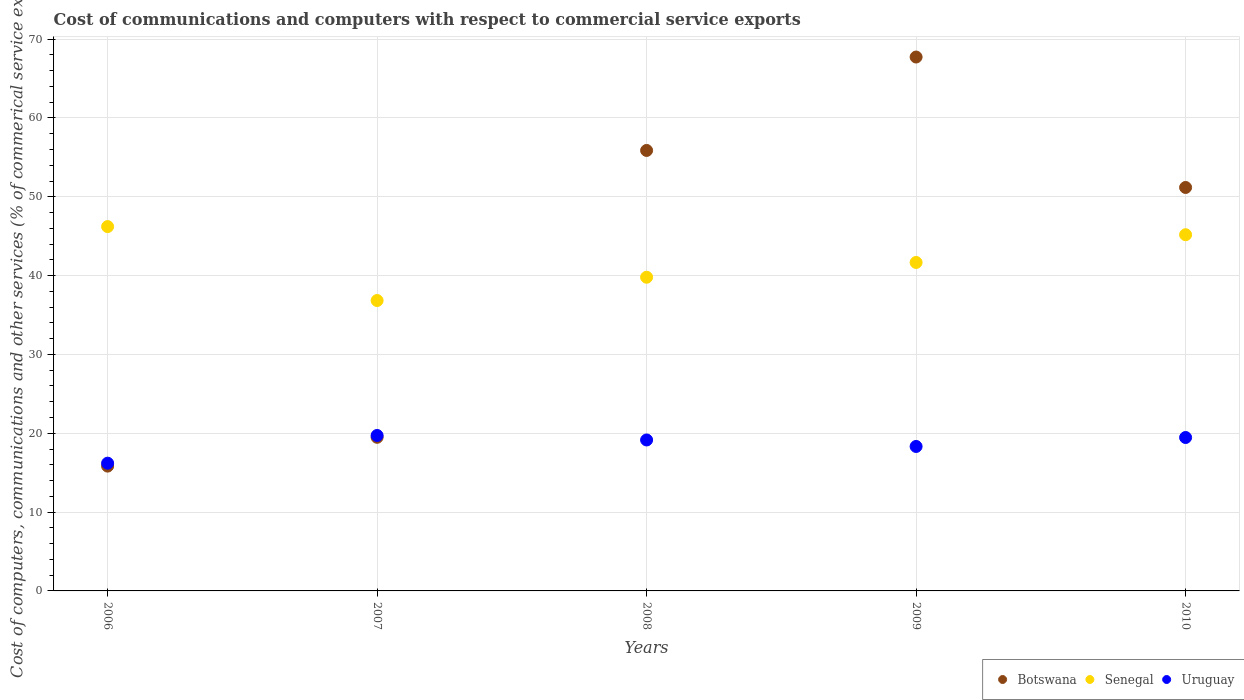What is the cost of communications and computers in Botswana in 2010?
Give a very brief answer. 51.18. Across all years, what is the maximum cost of communications and computers in Uruguay?
Keep it short and to the point. 19.72. Across all years, what is the minimum cost of communications and computers in Botswana?
Your answer should be very brief. 15.83. In which year was the cost of communications and computers in Senegal maximum?
Your response must be concise. 2006. In which year was the cost of communications and computers in Senegal minimum?
Your answer should be very brief. 2007. What is the total cost of communications and computers in Botswana in the graph?
Your answer should be compact. 210.1. What is the difference between the cost of communications and computers in Uruguay in 2006 and that in 2009?
Your answer should be very brief. -2.12. What is the difference between the cost of communications and computers in Senegal in 2010 and the cost of communications and computers in Botswana in 2008?
Your answer should be very brief. -10.69. What is the average cost of communications and computers in Senegal per year?
Your answer should be compact. 41.94. In the year 2008, what is the difference between the cost of communications and computers in Botswana and cost of communications and computers in Uruguay?
Keep it short and to the point. 36.73. In how many years, is the cost of communications and computers in Botswana greater than 58 %?
Offer a very short reply. 1. What is the ratio of the cost of communications and computers in Senegal in 2007 to that in 2010?
Your answer should be very brief. 0.82. Is the difference between the cost of communications and computers in Botswana in 2007 and 2009 greater than the difference between the cost of communications and computers in Uruguay in 2007 and 2009?
Ensure brevity in your answer.  No. What is the difference between the highest and the second highest cost of communications and computers in Senegal?
Give a very brief answer. 1.03. What is the difference between the highest and the lowest cost of communications and computers in Uruguay?
Give a very brief answer. 3.52. In how many years, is the cost of communications and computers in Uruguay greater than the average cost of communications and computers in Uruguay taken over all years?
Offer a very short reply. 3. Is the cost of communications and computers in Senegal strictly greater than the cost of communications and computers in Botswana over the years?
Your answer should be very brief. No. Is the cost of communications and computers in Botswana strictly less than the cost of communications and computers in Uruguay over the years?
Offer a terse response. No. How many years are there in the graph?
Keep it short and to the point. 5. Does the graph contain any zero values?
Your answer should be compact. No. Does the graph contain grids?
Offer a very short reply. Yes. How are the legend labels stacked?
Ensure brevity in your answer.  Horizontal. What is the title of the graph?
Your answer should be very brief. Cost of communications and computers with respect to commercial service exports. What is the label or title of the Y-axis?
Give a very brief answer. Cost of computers, communications and other services (% of commerical service exports). What is the Cost of computers, communications and other services (% of commerical service exports) in Botswana in 2006?
Your answer should be compact. 15.83. What is the Cost of computers, communications and other services (% of commerical service exports) in Senegal in 2006?
Provide a short and direct response. 46.22. What is the Cost of computers, communications and other services (% of commerical service exports) in Uruguay in 2006?
Offer a terse response. 16.2. What is the Cost of computers, communications and other services (% of commerical service exports) in Botswana in 2007?
Make the answer very short. 19.49. What is the Cost of computers, communications and other services (% of commerical service exports) in Senegal in 2007?
Your answer should be very brief. 36.84. What is the Cost of computers, communications and other services (% of commerical service exports) in Uruguay in 2007?
Your response must be concise. 19.72. What is the Cost of computers, communications and other services (% of commerical service exports) of Botswana in 2008?
Provide a succinct answer. 55.88. What is the Cost of computers, communications and other services (% of commerical service exports) in Senegal in 2008?
Offer a terse response. 39.79. What is the Cost of computers, communications and other services (% of commerical service exports) of Uruguay in 2008?
Make the answer very short. 19.15. What is the Cost of computers, communications and other services (% of commerical service exports) in Botswana in 2009?
Provide a succinct answer. 67.73. What is the Cost of computers, communications and other services (% of commerical service exports) of Senegal in 2009?
Provide a short and direct response. 41.67. What is the Cost of computers, communications and other services (% of commerical service exports) in Uruguay in 2009?
Your answer should be compact. 18.33. What is the Cost of computers, communications and other services (% of commerical service exports) in Botswana in 2010?
Your response must be concise. 51.18. What is the Cost of computers, communications and other services (% of commerical service exports) in Senegal in 2010?
Your response must be concise. 45.18. What is the Cost of computers, communications and other services (% of commerical service exports) of Uruguay in 2010?
Provide a short and direct response. 19.46. Across all years, what is the maximum Cost of computers, communications and other services (% of commerical service exports) in Botswana?
Give a very brief answer. 67.73. Across all years, what is the maximum Cost of computers, communications and other services (% of commerical service exports) of Senegal?
Ensure brevity in your answer.  46.22. Across all years, what is the maximum Cost of computers, communications and other services (% of commerical service exports) of Uruguay?
Give a very brief answer. 19.72. Across all years, what is the minimum Cost of computers, communications and other services (% of commerical service exports) in Botswana?
Your answer should be compact. 15.83. Across all years, what is the minimum Cost of computers, communications and other services (% of commerical service exports) of Senegal?
Provide a succinct answer. 36.84. Across all years, what is the minimum Cost of computers, communications and other services (% of commerical service exports) in Uruguay?
Offer a terse response. 16.2. What is the total Cost of computers, communications and other services (% of commerical service exports) of Botswana in the graph?
Offer a terse response. 210.1. What is the total Cost of computers, communications and other services (% of commerical service exports) of Senegal in the graph?
Give a very brief answer. 209.7. What is the total Cost of computers, communications and other services (% of commerical service exports) in Uruguay in the graph?
Keep it short and to the point. 92.86. What is the difference between the Cost of computers, communications and other services (% of commerical service exports) of Botswana in 2006 and that in 2007?
Your answer should be compact. -3.65. What is the difference between the Cost of computers, communications and other services (% of commerical service exports) of Senegal in 2006 and that in 2007?
Provide a succinct answer. 9.38. What is the difference between the Cost of computers, communications and other services (% of commerical service exports) of Uruguay in 2006 and that in 2007?
Your response must be concise. -3.52. What is the difference between the Cost of computers, communications and other services (% of commerical service exports) in Botswana in 2006 and that in 2008?
Give a very brief answer. -40.04. What is the difference between the Cost of computers, communications and other services (% of commerical service exports) in Senegal in 2006 and that in 2008?
Give a very brief answer. 6.42. What is the difference between the Cost of computers, communications and other services (% of commerical service exports) in Uruguay in 2006 and that in 2008?
Keep it short and to the point. -2.94. What is the difference between the Cost of computers, communications and other services (% of commerical service exports) in Botswana in 2006 and that in 2009?
Make the answer very short. -51.89. What is the difference between the Cost of computers, communications and other services (% of commerical service exports) of Senegal in 2006 and that in 2009?
Your answer should be compact. 4.55. What is the difference between the Cost of computers, communications and other services (% of commerical service exports) of Uruguay in 2006 and that in 2009?
Ensure brevity in your answer.  -2.12. What is the difference between the Cost of computers, communications and other services (% of commerical service exports) of Botswana in 2006 and that in 2010?
Offer a very short reply. -35.34. What is the difference between the Cost of computers, communications and other services (% of commerical service exports) of Senegal in 2006 and that in 2010?
Provide a short and direct response. 1.03. What is the difference between the Cost of computers, communications and other services (% of commerical service exports) in Uruguay in 2006 and that in 2010?
Make the answer very short. -3.26. What is the difference between the Cost of computers, communications and other services (% of commerical service exports) of Botswana in 2007 and that in 2008?
Ensure brevity in your answer.  -36.39. What is the difference between the Cost of computers, communications and other services (% of commerical service exports) in Senegal in 2007 and that in 2008?
Your response must be concise. -2.95. What is the difference between the Cost of computers, communications and other services (% of commerical service exports) of Uruguay in 2007 and that in 2008?
Keep it short and to the point. 0.57. What is the difference between the Cost of computers, communications and other services (% of commerical service exports) of Botswana in 2007 and that in 2009?
Offer a very short reply. -48.24. What is the difference between the Cost of computers, communications and other services (% of commerical service exports) in Senegal in 2007 and that in 2009?
Your answer should be very brief. -4.83. What is the difference between the Cost of computers, communications and other services (% of commerical service exports) of Uruguay in 2007 and that in 2009?
Make the answer very short. 1.39. What is the difference between the Cost of computers, communications and other services (% of commerical service exports) in Botswana in 2007 and that in 2010?
Your response must be concise. -31.69. What is the difference between the Cost of computers, communications and other services (% of commerical service exports) in Senegal in 2007 and that in 2010?
Offer a terse response. -8.35. What is the difference between the Cost of computers, communications and other services (% of commerical service exports) of Uruguay in 2007 and that in 2010?
Your answer should be very brief. 0.26. What is the difference between the Cost of computers, communications and other services (% of commerical service exports) of Botswana in 2008 and that in 2009?
Provide a succinct answer. -11.85. What is the difference between the Cost of computers, communications and other services (% of commerical service exports) of Senegal in 2008 and that in 2009?
Offer a terse response. -1.87. What is the difference between the Cost of computers, communications and other services (% of commerical service exports) of Uruguay in 2008 and that in 2009?
Keep it short and to the point. 0.82. What is the difference between the Cost of computers, communications and other services (% of commerical service exports) of Botswana in 2008 and that in 2010?
Your answer should be compact. 4.7. What is the difference between the Cost of computers, communications and other services (% of commerical service exports) in Senegal in 2008 and that in 2010?
Provide a succinct answer. -5.39. What is the difference between the Cost of computers, communications and other services (% of commerical service exports) of Uruguay in 2008 and that in 2010?
Offer a terse response. -0.31. What is the difference between the Cost of computers, communications and other services (% of commerical service exports) in Botswana in 2009 and that in 2010?
Ensure brevity in your answer.  16.55. What is the difference between the Cost of computers, communications and other services (% of commerical service exports) of Senegal in 2009 and that in 2010?
Offer a very short reply. -3.52. What is the difference between the Cost of computers, communications and other services (% of commerical service exports) of Uruguay in 2009 and that in 2010?
Offer a very short reply. -1.14. What is the difference between the Cost of computers, communications and other services (% of commerical service exports) in Botswana in 2006 and the Cost of computers, communications and other services (% of commerical service exports) in Senegal in 2007?
Ensure brevity in your answer.  -21. What is the difference between the Cost of computers, communications and other services (% of commerical service exports) of Botswana in 2006 and the Cost of computers, communications and other services (% of commerical service exports) of Uruguay in 2007?
Make the answer very short. -3.89. What is the difference between the Cost of computers, communications and other services (% of commerical service exports) in Senegal in 2006 and the Cost of computers, communications and other services (% of commerical service exports) in Uruguay in 2007?
Provide a succinct answer. 26.5. What is the difference between the Cost of computers, communications and other services (% of commerical service exports) of Botswana in 2006 and the Cost of computers, communications and other services (% of commerical service exports) of Senegal in 2008?
Give a very brief answer. -23.96. What is the difference between the Cost of computers, communications and other services (% of commerical service exports) of Botswana in 2006 and the Cost of computers, communications and other services (% of commerical service exports) of Uruguay in 2008?
Offer a terse response. -3.32. What is the difference between the Cost of computers, communications and other services (% of commerical service exports) of Senegal in 2006 and the Cost of computers, communications and other services (% of commerical service exports) of Uruguay in 2008?
Your answer should be compact. 27.07. What is the difference between the Cost of computers, communications and other services (% of commerical service exports) of Botswana in 2006 and the Cost of computers, communications and other services (% of commerical service exports) of Senegal in 2009?
Provide a succinct answer. -25.83. What is the difference between the Cost of computers, communications and other services (% of commerical service exports) in Botswana in 2006 and the Cost of computers, communications and other services (% of commerical service exports) in Uruguay in 2009?
Keep it short and to the point. -2.49. What is the difference between the Cost of computers, communications and other services (% of commerical service exports) of Senegal in 2006 and the Cost of computers, communications and other services (% of commerical service exports) of Uruguay in 2009?
Ensure brevity in your answer.  27.89. What is the difference between the Cost of computers, communications and other services (% of commerical service exports) in Botswana in 2006 and the Cost of computers, communications and other services (% of commerical service exports) in Senegal in 2010?
Make the answer very short. -29.35. What is the difference between the Cost of computers, communications and other services (% of commerical service exports) in Botswana in 2006 and the Cost of computers, communications and other services (% of commerical service exports) in Uruguay in 2010?
Provide a succinct answer. -3.63. What is the difference between the Cost of computers, communications and other services (% of commerical service exports) in Senegal in 2006 and the Cost of computers, communications and other services (% of commerical service exports) in Uruguay in 2010?
Make the answer very short. 26.76. What is the difference between the Cost of computers, communications and other services (% of commerical service exports) in Botswana in 2007 and the Cost of computers, communications and other services (% of commerical service exports) in Senegal in 2008?
Provide a short and direct response. -20.3. What is the difference between the Cost of computers, communications and other services (% of commerical service exports) in Botswana in 2007 and the Cost of computers, communications and other services (% of commerical service exports) in Uruguay in 2008?
Provide a short and direct response. 0.34. What is the difference between the Cost of computers, communications and other services (% of commerical service exports) of Senegal in 2007 and the Cost of computers, communications and other services (% of commerical service exports) of Uruguay in 2008?
Give a very brief answer. 17.69. What is the difference between the Cost of computers, communications and other services (% of commerical service exports) of Botswana in 2007 and the Cost of computers, communications and other services (% of commerical service exports) of Senegal in 2009?
Provide a short and direct response. -22.18. What is the difference between the Cost of computers, communications and other services (% of commerical service exports) of Botswana in 2007 and the Cost of computers, communications and other services (% of commerical service exports) of Uruguay in 2009?
Make the answer very short. 1.16. What is the difference between the Cost of computers, communications and other services (% of commerical service exports) in Senegal in 2007 and the Cost of computers, communications and other services (% of commerical service exports) in Uruguay in 2009?
Provide a succinct answer. 18.51. What is the difference between the Cost of computers, communications and other services (% of commerical service exports) in Botswana in 2007 and the Cost of computers, communications and other services (% of commerical service exports) in Senegal in 2010?
Give a very brief answer. -25.7. What is the difference between the Cost of computers, communications and other services (% of commerical service exports) in Botswana in 2007 and the Cost of computers, communications and other services (% of commerical service exports) in Uruguay in 2010?
Provide a succinct answer. 0.03. What is the difference between the Cost of computers, communications and other services (% of commerical service exports) of Senegal in 2007 and the Cost of computers, communications and other services (% of commerical service exports) of Uruguay in 2010?
Provide a short and direct response. 17.38. What is the difference between the Cost of computers, communications and other services (% of commerical service exports) of Botswana in 2008 and the Cost of computers, communications and other services (% of commerical service exports) of Senegal in 2009?
Provide a succinct answer. 14.21. What is the difference between the Cost of computers, communications and other services (% of commerical service exports) of Botswana in 2008 and the Cost of computers, communications and other services (% of commerical service exports) of Uruguay in 2009?
Give a very brief answer. 37.55. What is the difference between the Cost of computers, communications and other services (% of commerical service exports) of Senegal in 2008 and the Cost of computers, communications and other services (% of commerical service exports) of Uruguay in 2009?
Your response must be concise. 21.47. What is the difference between the Cost of computers, communications and other services (% of commerical service exports) in Botswana in 2008 and the Cost of computers, communications and other services (% of commerical service exports) in Senegal in 2010?
Your answer should be very brief. 10.69. What is the difference between the Cost of computers, communications and other services (% of commerical service exports) in Botswana in 2008 and the Cost of computers, communications and other services (% of commerical service exports) in Uruguay in 2010?
Make the answer very short. 36.41. What is the difference between the Cost of computers, communications and other services (% of commerical service exports) of Senegal in 2008 and the Cost of computers, communications and other services (% of commerical service exports) of Uruguay in 2010?
Offer a terse response. 20.33. What is the difference between the Cost of computers, communications and other services (% of commerical service exports) of Botswana in 2009 and the Cost of computers, communications and other services (% of commerical service exports) of Senegal in 2010?
Offer a terse response. 22.54. What is the difference between the Cost of computers, communications and other services (% of commerical service exports) in Botswana in 2009 and the Cost of computers, communications and other services (% of commerical service exports) in Uruguay in 2010?
Your answer should be very brief. 48.27. What is the difference between the Cost of computers, communications and other services (% of commerical service exports) of Senegal in 2009 and the Cost of computers, communications and other services (% of commerical service exports) of Uruguay in 2010?
Make the answer very short. 22.2. What is the average Cost of computers, communications and other services (% of commerical service exports) in Botswana per year?
Your response must be concise. 42.02. What is the average Cost of computers, communications and other services (% of commerical service exports) of Senegal per year?
Provide a succinct answer. 41.94. What is the average Cost of computers, communications and other services (% of commerical service exports) of Uruguay per year?
Your answer should be very brief. 18.57. In the year 2006, what is the difference between the Cost of computers, communications and other services (% of commerical service exports) of Botswana and Cost of computers, communications and other services (% of commerical service exports) of Senegal?
Your response must be concise. -30.38. In the year 2006, what is the difference between the Cost of computers, communications and other services (% of commerical service exports) in Botswana and Cost of computers, communications and other services (% of commerical service exports) in Uruguay?
Keep it short and to the point. -0.37. In the year 2006, what is the difference between the Cost of computers, communications and other services (% of commerical service exports) of Senegal and Cost of computers, communications and other services (% of commerical service exports) of Uruguay?
Your answer should be very brief. 30.01. In the year 2007, what is the difference between the Cost of computers, communications and other services (% of commerical service exports) of Botswana and Cost of computers, communications and other services (% of commerical service exports) of Senegal?
Your response must be concise. -17.35. In the year 2007, what is the difference between the Cost of computers, communications and other services (% of commerical service exports) in Botswana and Cost of computers, communications and other services (% of commerical service exports) in Uruguay?
Your answer should be compact. -0.23. In the year 2007, what is the difference between the Cost of computers, communications and other services (% of commerical service exports) in Senegal and Cost of computers, communications and other services (% of commerical service exports) in Uruguay?
Provide a short and direct response. 17.12. In the year 2008, what is the difference between the Cost of computers, communications and other services (% of commerical service exports) of Botswana and Cost of computers, communications and other services (% of commerical service exports) of Senegal?
Offer a very short reply. 16.08. In the year 2008, what is the difference between the Cost of computers, communications and other services (% of commerical service exports) in Botswana and Cost of computers, communications and other services (% of commerical service exports) in Uruguay?
Ensure brevity in your answer.  36.73. In the year 2008, what is the difference between the Cost of computers, communications and other services (% of commerical service exports) of Senegal and Cost of computers, communications and other services (% of commerical service exports) of Uruguay?
Offer a very short reply. 20.64. In the year 2009, what is the difference between the Cost of computers, communications and other services (% of commerical service exports) of Botswana and Cost of computers, communications and other services (% of commerical service exports) of Senegal?
Offer a terse response. 26.06. In the year 2009, what is the difference between the Cost of computers, communications and other services (% of commerical service exports) in Botswana and Cost of computers, communications and other services (% of commerical service exports) in Uruguay?
Offer a very short reply. 49.4. In the year 2009, what is the difference between the Cost of computers, communications and other services (% of commerical service exports) in Senegal and Cost of computers, communications and other services (% of commerical service exports) in Uruguay?
Offer a terse response. 23.34. In the year 2010, what is the difference between the Cost of computers, communications and other services (% of commerical service exports) of Botswana and Cost of computers, communications and other services (% of commerical service exports) of Senegal?
Your answer should be compact. 5.99. In the year 2010, what is the difference between the Cost of computers, communications and other services (% of commerical service exports) in Botswana and Cost of computers, communications and other services (% of commerical service exports) in Uruguay?
Provide a succinct answer. 31.72. In the year 2010, what is the difference between the Cost of computers, communications and other services (% of commerical service exports) in Senegal and Cost of computers, communications and other services (% of commerical service exports) in Uruguay?
Provide a succinct answer. 25.72. What is the ratio of the Cost of computers, communications and other services (% of commerical service exports) in Botswana in 2006 to that in 2007?
Provide a short and direct response. 0.81. What is the ratio of the Cost of computers, communications and other services (% of commerical service exports) of Senegal in 2006 to that in 2007?
Provide a short and direct response. 1.25. What is the ratio of the Cost of computers, communications and other services (% of commerical service exports) in Uruguay in 2006 to that in 2007?
Offer a very short reply. 0.82. What is the ratio of the Cost of computers, communications and other services (% of commerical service exports) of Botswana in 2006 to that in 2008?
Provide a succinct answer. 0.28. What is the ratio of the Cost of computers, communications and other services (% of commerical service exports) in Senegal in 2006 to that in 2008?
Your response must be concise. 1.16. What is the ratio of the Cost of computers, communications and other services (% of commerical service exports) in Uruguay in 2006 to that in 2008?
Ensure brevity in your answer.  0.85. What is the ratio of the Cost of computers, communications and other services (% of commerical service exports) of Botswana in 2006 to that in 2009?
Provide a succinct answer. 0.23. What is the ratio of the Cost of computers, communications and other services (% of commerical service exports) of Senegal in 2006 to that in 2009?
Give a very brief answer. 1.11. What is the ratio of the Cost of computers, communications and other services (% of commerical service exports) in Uruguay in 2006 to that in 2009?
Ensure brevity in your answer.  0.88. What is the ratio of the Cost of computers, communications and other services (% of commerical service exports) in Botswana in 2006 to that in 2010?
Ensure brevity in your answer.  0.31. What is the ratio of the Cost of computers, communications and other services (% of commerical service exports) in Senegal in 2006 to that in 2010?
Provide a short and direct response. 1.02. What is the ratio of the Cost of computers, communications and other services (% of commerical service exports) of Uruguay in 2006 to that in 2010?
Provide a succinct answer. 0.83. What is the ratio of the Cost of computers, communications and other services (% of commerical service exports) in Botswana in 2007 to that in 2008?
Provide a succinct answer. 0.35. What is the ratio of the Cost of computers, communications and other services (% of commerical service exports) in Senegal in 2007 to that in 2008?
Your answer should be very brief. 0.93. What is the ratio of the Cost of computers, communications and other services (% of commerical service exports) in Uruguay in 2007 to that in 2008?
Give a very brief answer. 1.03. What is the ratio of the Cost of computers, communications and other services (% of commerical service exports) in Botswana in 2007 to that in 2009?
Ensure brevity in your answer.  0.29. What is the ratio of the Cost of computers, communications and other services (% of commerical service exports) in Senegal in 2007 to that in 2009?
Offer a very short reply. 0.88. What is the ratio of the Cost of computers, communications and other services (% of commerical service exports) of Uruguay in 2007 to that in 2009?
Offer a terse response. 1.08. What is the ratio of the Cost of computers, communications and other services (% of commerical service exports) of Botswana in 2007 to that in 2010?
Make the answer very short. 0.38. What is the ratio of the Cost of computers, communications and other services (% of commerical service exports) of Senegal in 2007 to that in 2010?
Your answer should be compact. 0.82. What is the ratio of the Cost of computers, communications and other services (% of commerical service exports) in Uruguay in 2007 to that in 2010?
Give a very brief answer. 1.01. What is the ratio of the Cost of computers, communications and other services (% of commerical service exports) of Botswana in 2008 to that in 2009?
Provide a succinct answer. 0.82. What is the ratio of the Cost of computers, communications and other services (% of commerical service exports) in Senegal in 2008 to that in 2009?
Your response must be concise. 0.95. What is the ratio of the Cost of computers, communications and other services (% of commerical service exports) of Uruguay in 2008 to that in 2009?
Ensure brevity in your answer.  1.04. What is the ratio of the Cost of computers, communications and other services (% of commerical service exports) of Botswana in 2008 to that in 2010?
Your response must be concise. 1.09. What is the ratio of the Cost of computers, communications and other services (% of commerical service exports) in Senegal in 2008 to that in 2010?
Offer a terse response. 0.88. What is the ratio of the Cost of computers, communications and other services (% of commerical service exports) in Uruguay in 2008 to that in 2010?
Give a very brief answer. 0.98. What is the ratio of the Cost of computers, communications and other services (% of commerical service exports) in Botswana in 2009 to that in 2010?
Your response must be concise. 1.32. What is the ratio of the Cost of computers, communications and other services (% of commerical service exports) of Senegal in 2009 to that in 2010?
Give a very brief answer. 0.92. What is the ratio of the Cost of computers, communications and other services (% of commerical service exports) in Uruguay in 2009 to that in 2010?
Keep it short and to the point. 0.94. What is the difference between the highest and the second highest Cost of computers, communications and other services (% of commerical service exports) in Botswana?
Make the answer very short. 11.85. What is the difference between the highest and the second highest Cost of computers, communications and other services (% of commerical service exports) of Senegal?
Your answer should be very brief. 1.03. What is the difference between the highest and the second highest Cost of computers, communications and other services (% of commerical service exports) of Uruguay?
Offer a very short reply. 0.26. What is the difference between the highest and the lowest Cost of computers, communications and other services (% of commerical service exports) of Botswana?
Provide a succinct answer. 51.89. What is the difference between the highest and the lowest Cost of computers, communications and other services (% of commerical service exports) in Senegal?
Your answer should be compact. 9.38. What is the difference between the highest and the lowest Cost of computers, communications and other services (% of commerical service exports) of Uruguay?
Offer a terse response. 3.52. 